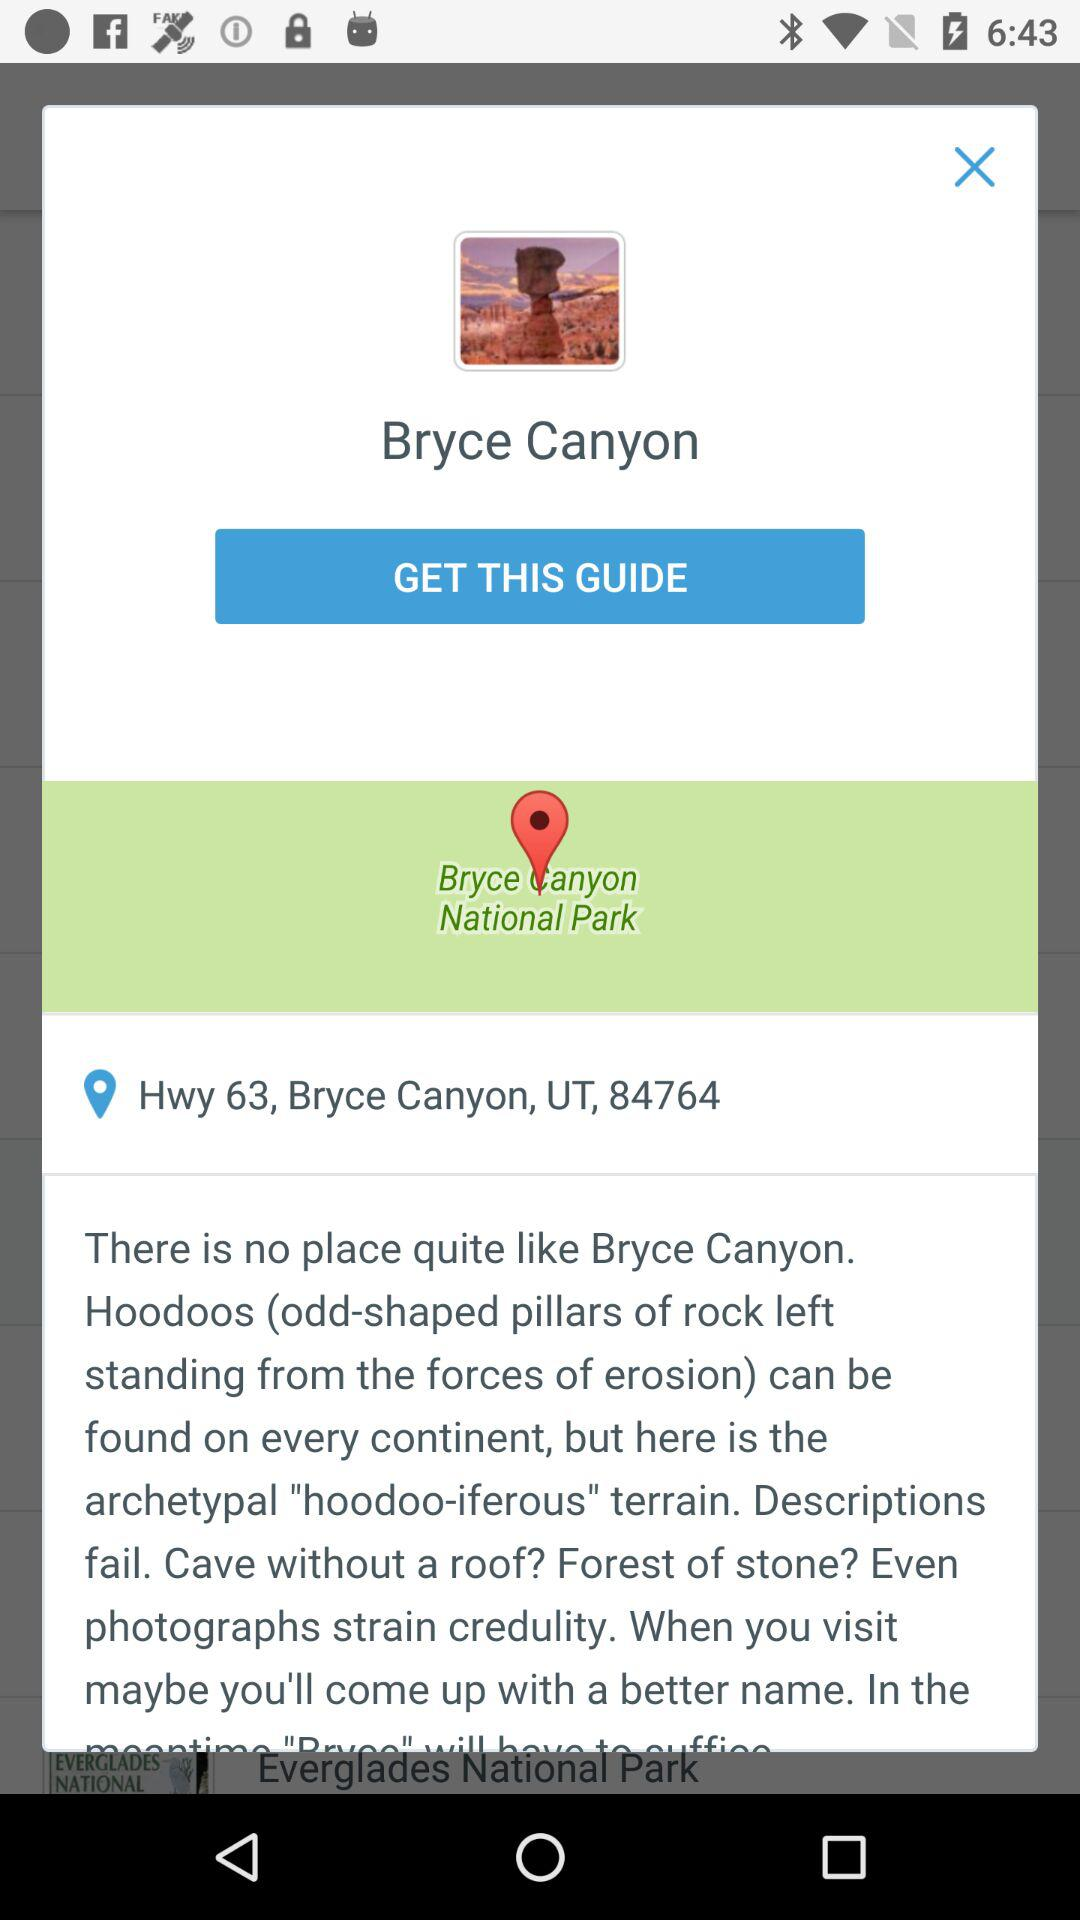What is the name of the national park? The name of the national park is "Bryce Canyon". 